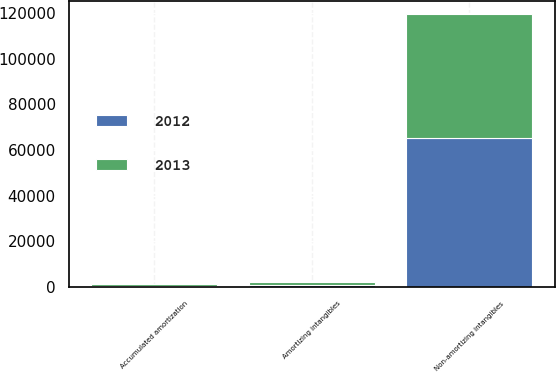Convert chart. <chart><loc_0><loc_0><loc_500><loc_500><stacked_bar_chart><ecel><fcel>Amortizing intangibles<fcel>Accumulated amortization<fcel>Non-amortizing intangibles<nl><fcel>2012<fcel>1076<fcel>590<fcel>65288<nl><fcel>2013<fcel>1061<fcel>553<fcel>54140<nl></chart> 